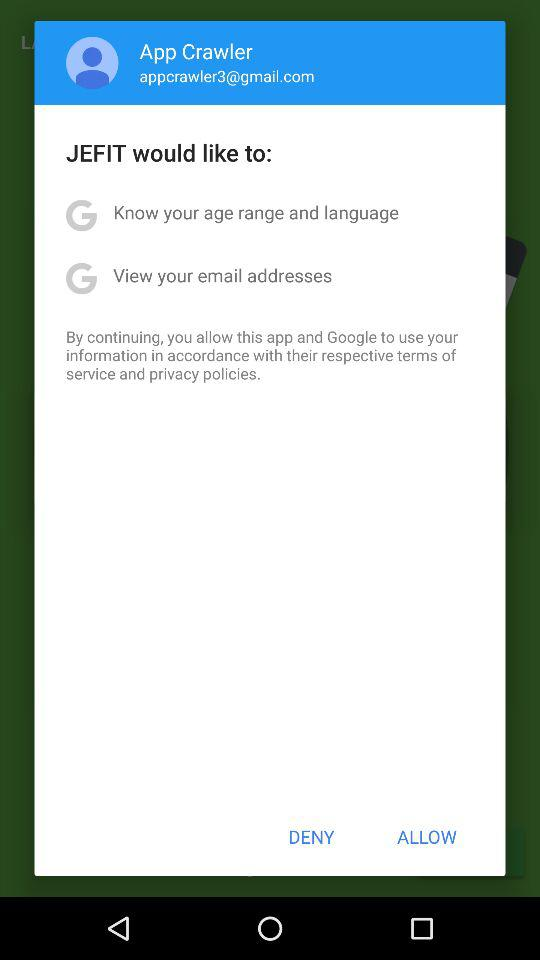What is the email address? The email address is appcrawler3@gmail.com. 